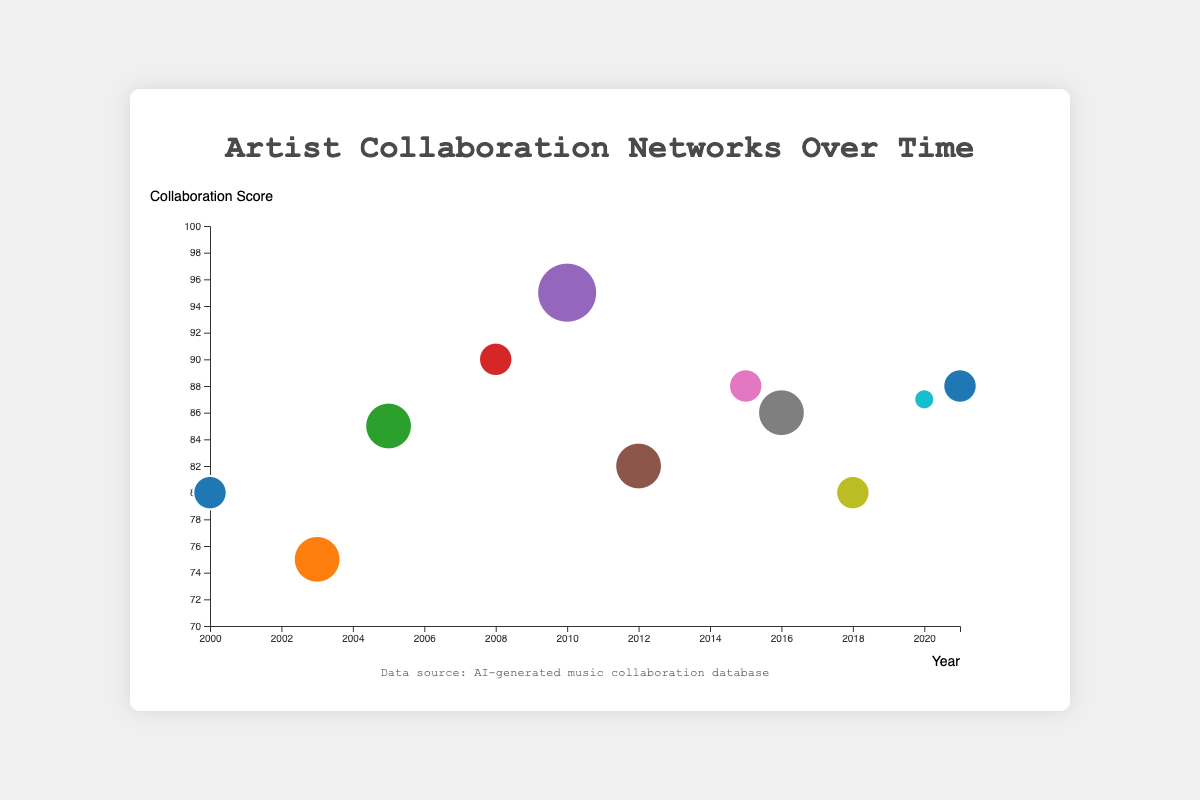What's the title of the chart? The title is located at the top of the chart, usually in a larger and bold font. It's a descriptive text that tells us what the chart is about.
Answer: Artist Collaboration Networks Over Time How many collaborations had a collaboration score of 85 or higher? We need to count the number of data points with a collaboration score greater than or equal to 85.
Answer: 7 Which collaboration involved the most number of hits? We need to look for the data point with the largest bubble because the size of the bubble represents the number of hits.
Answer: Eminem & Rihanna in 2010 What is the collaboration score range in the chart? Identify the smallest and largest values on the y-axis representing collaboration score. The range is from the minimum to the maximum value.
Answer: 75 to 95 How many collaborations occurred between 2010 and 2015? Look for data points where the year falls between 2010 and 2015 inclusive, and count them.
Answer: 3 Which collaboration had the highest collaboration score and occurred after 2018? Identify the data point with the highest collaboration score post-2018 by comparing the scores of bubbles for that period.
Answer: Doja Cat & SZA in 2021 How does the collaboration score of Kanye West & Jamie Foxx in 2005 compare to that of Jay-Z & Beyonce in 2000? Compare the positions of the respective data points on the y-axis corresponding to the collaboration scores.
Answer: Higher What is the average collaboration score of collaborations in the 2010s? First, extract the collaboration scores for the years from 2010 to 2019. Then, sum these scores and divide by the number of such collaborations.
Answer: (95 + 82 + 88 + 86) / 4 = 87.75 Which two artists had repeat collaborations in the data set, and when? Identify any artists that appear in more than one collaboration together and list the years.
Answer: Jay-Z & Beyonce in 2000 and Rihanna in 2008 